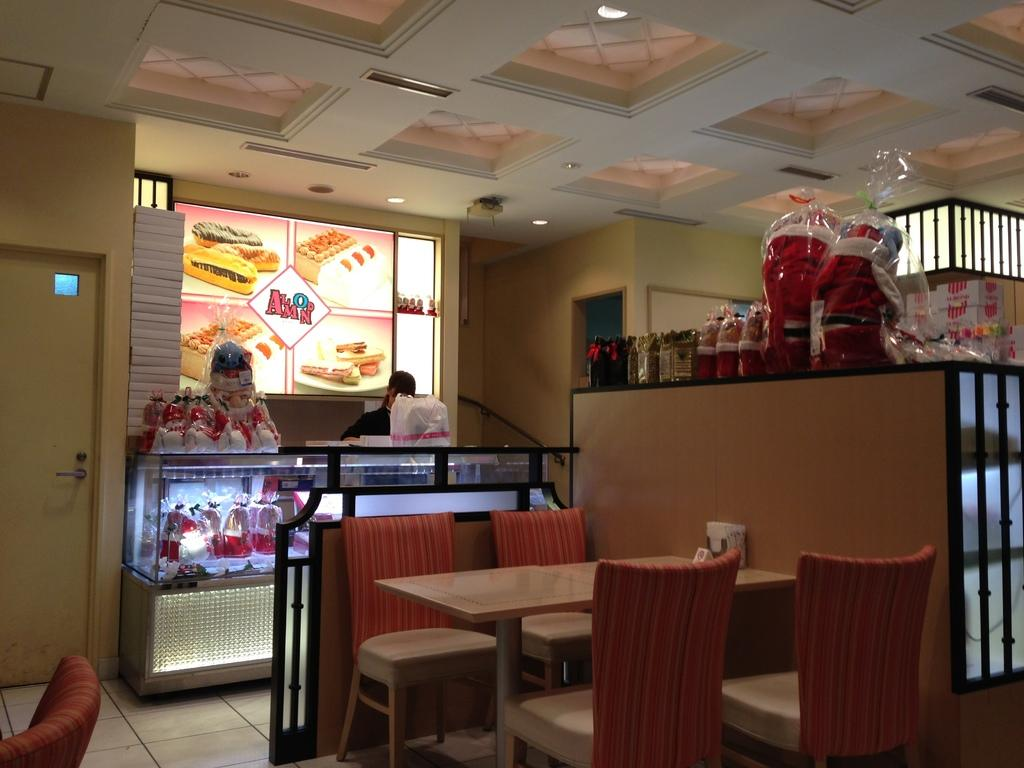What type of structure can be seen in the image? There is a wall in the image. What furniture is present in the image? There is a table, a stool, and chairs in the image. What is the color of the floor tiles in the image? The floor has white color tiles. Are there any openings in the wall in the image? Yes, there is a door in the image. Who is present in the image? There is a man standing in the image. What color is the zebra in the image? There is no zebra present in the image. Can you touch the wall in the image? You cannot touch the wall in the image, as it is a two-dimensional representation. 